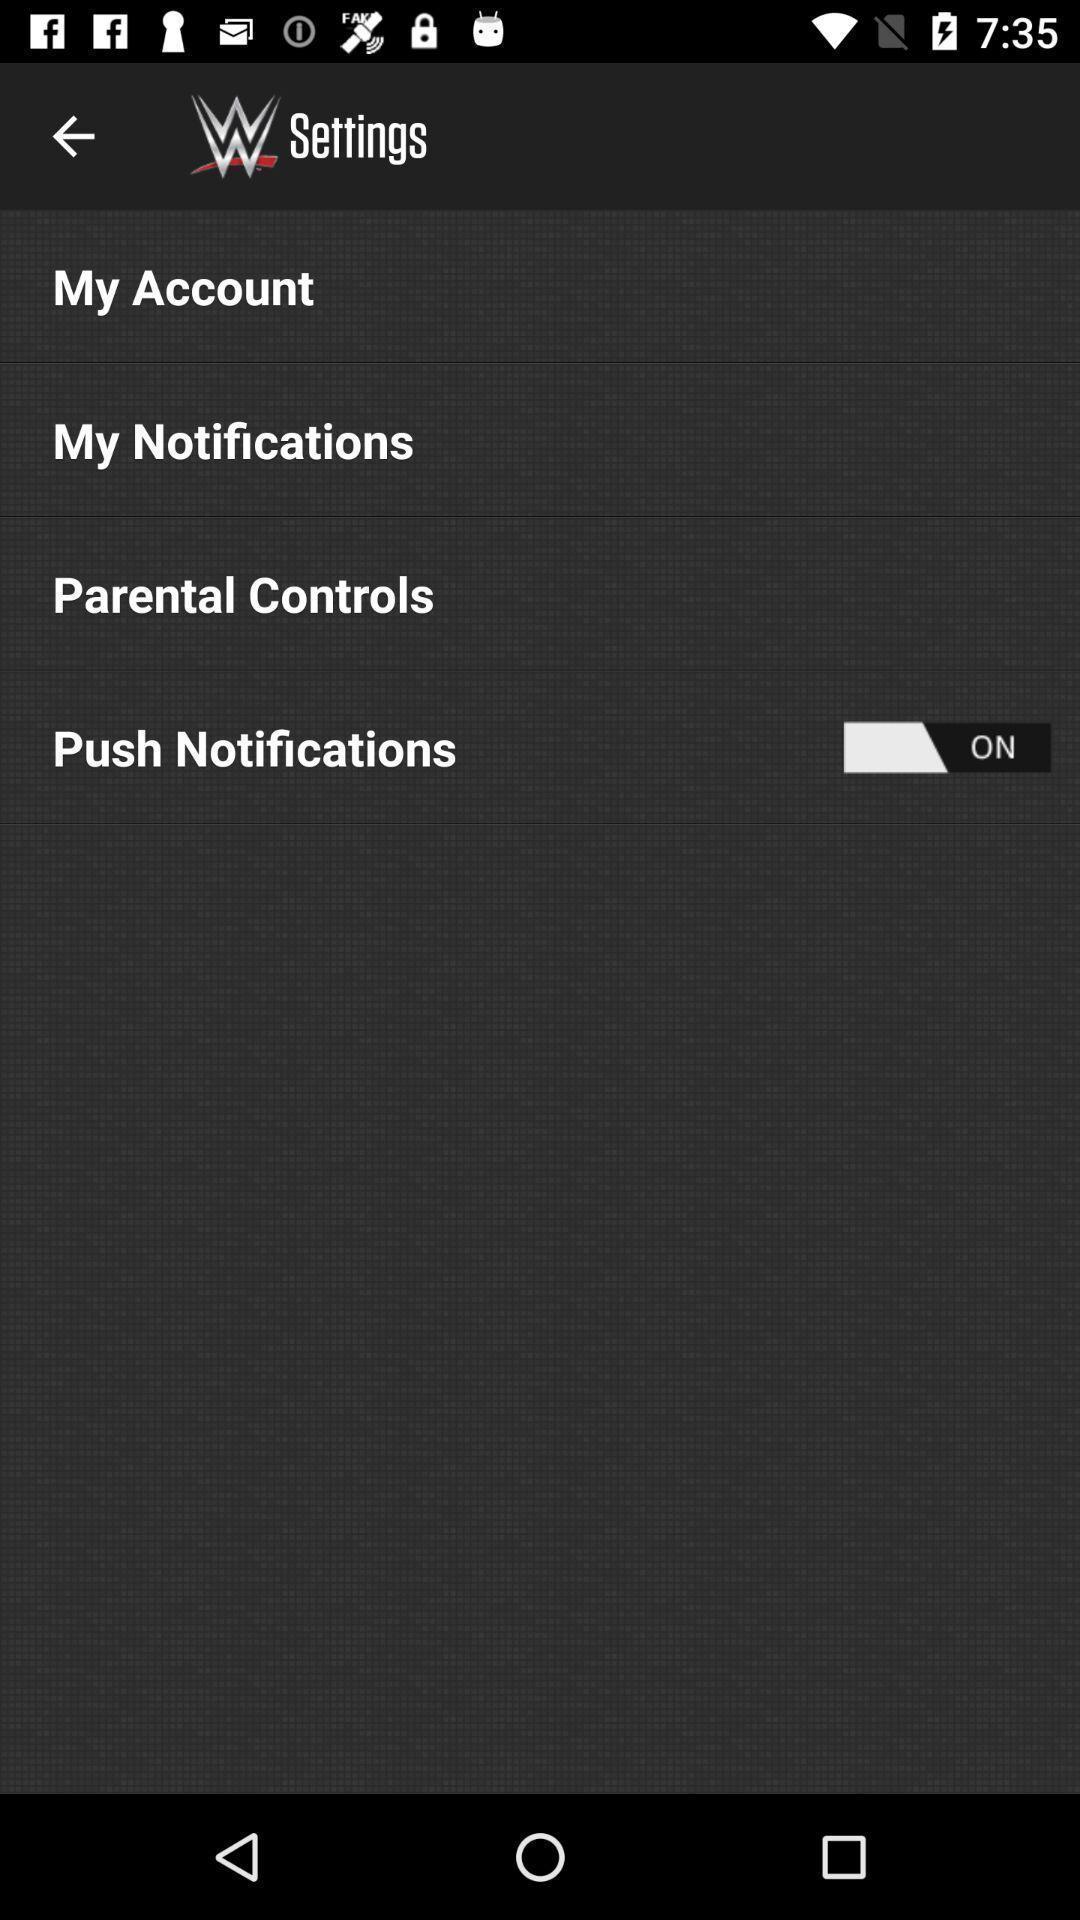Describe the content in this image. Settings page of a western frisian app. 